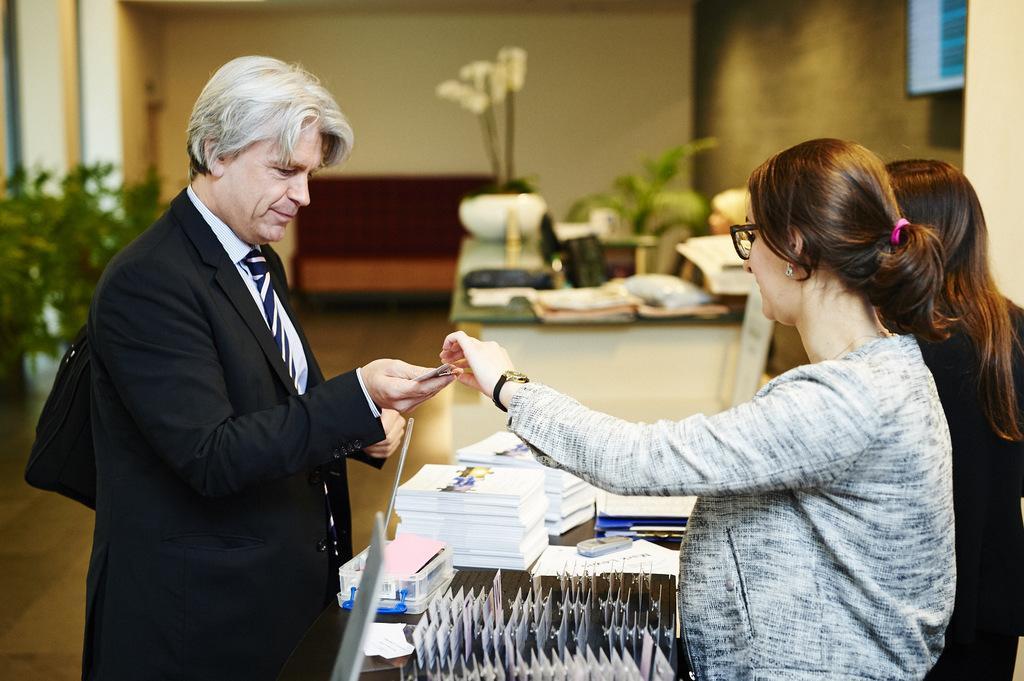In one or two sentences, can you explain what this image depicts? In this image we can see three persons standing. One person is wearing coat and holding a paper in his hand, One woman is wearing spectacles and a wrist watch on her hand. In the foreground we can see group of papers, box, some cards on a table. In the background, we can see group of plants, a sofa placed on the ground. A television on the wall and some lights. 